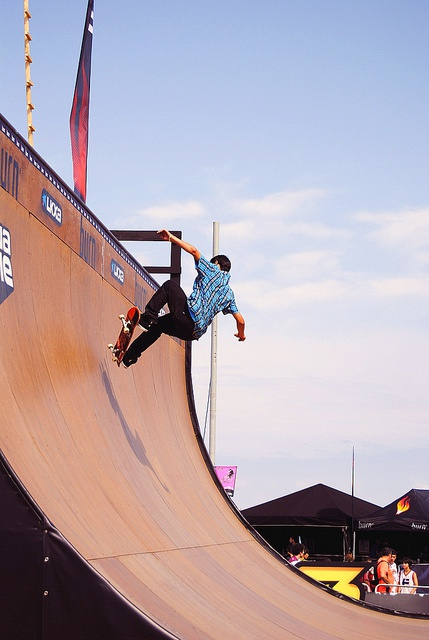Describe the objects in this image and their specific colors. I can see people in darkgray, black, lightgray, and lightblue tones, skateboard in darkgray, black, maroon, brown, and tan tones, people in darkgray, salmon, black, red, and tan tones, people in darkgray, lightgray, black, tan, and lightpink tones, and backpack in darkgray, black, maroon, and brown tones in this image. 